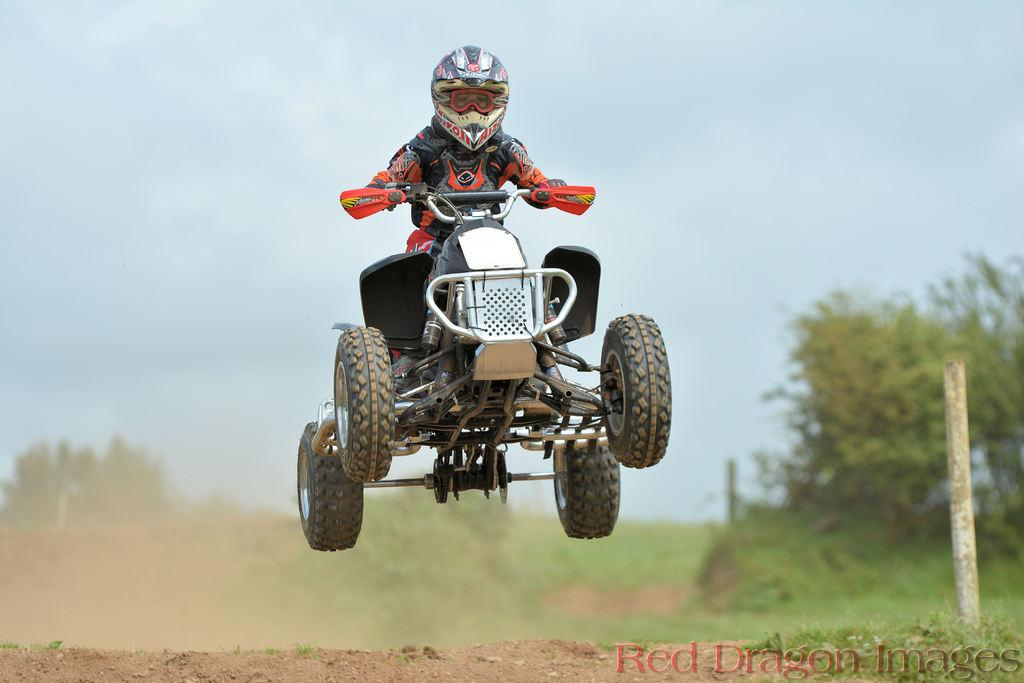What is the person in the image doing? The person is sitting on a vehicle in the image. What protective gear is the person wearing? The person is wearing a helmet. What can be seen in the background of the image? There is sky, grass, trees, and a pole visible in the background of the image. What type of addition problem can be solved using the numbers on the cannon in the image? There is no cannon present in the image, so no addition problem can be solved using it. What is the hose used for in the image? There is no hose present in the image, so its use cannot be determined. 